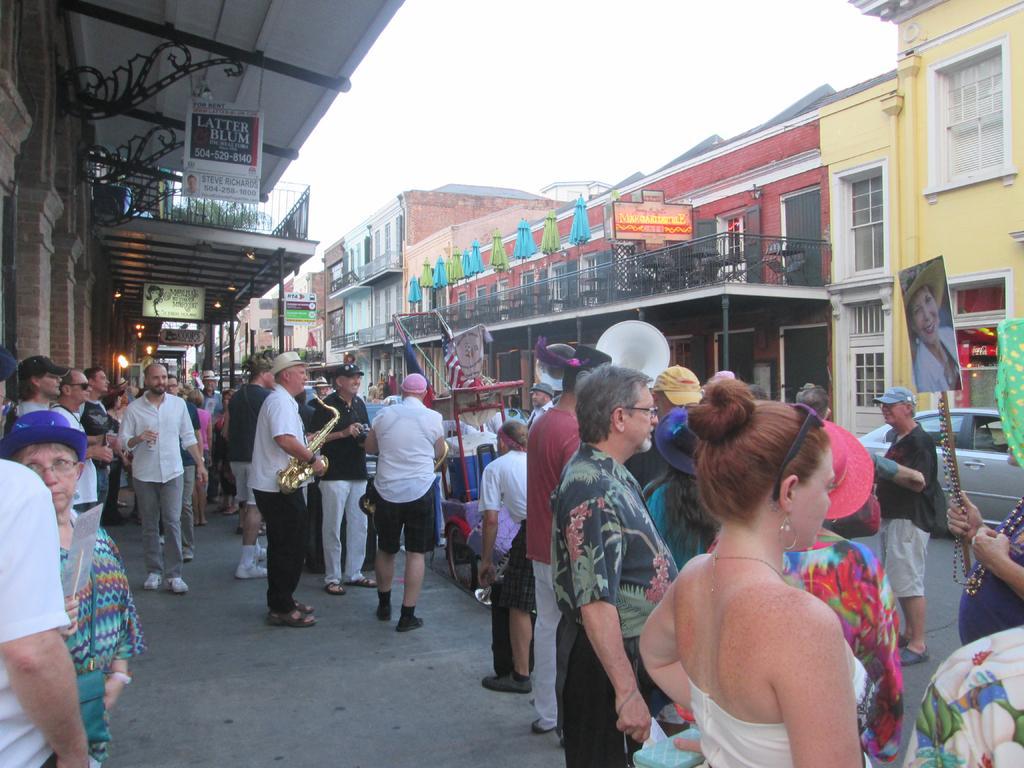Can you describe this image briefly? In this image we can see a group of people standing on the ground. In that a person is holding a board with the picture of a woman and the other is holding a trumpet. We can also see some vehicles on the road, some buildings with windows and fence, a signboard with some text on it, some umbrellas, lights, pillars, the flags and the sky which looks cloudy. 